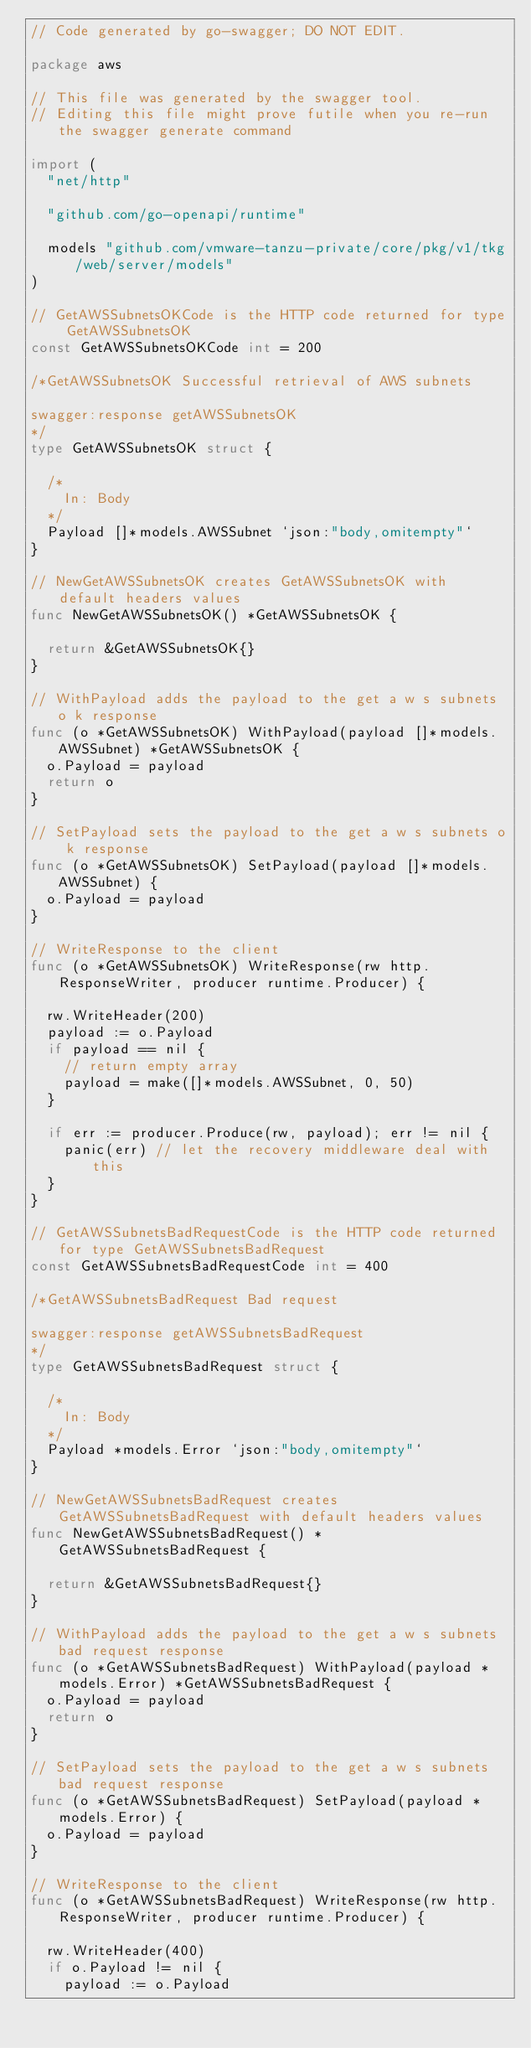Convert code to text. <code><loc_0><loc_0><loc_500><loc_500><_Go_>// Code generated by go-swagger; DO NOT EDIT.

package aws

// This file was generated by the swagger tool.
// Editing this file might prove futile when you re-run the swagger generate command

import (
	"net/http"

	"github.com/go-openapi/runtime"

	models "github.com/vmware-tanzu-private/core/pkg/v1/tkg/web/server/models"
)

// GetAWSSubnetsOKCode is the HTTP code returned for type GetAWSSubnetsOK
const GetAWSSubnetsOKCode int = 200

/*GetAWSSubnetsOK Successful retrieval of AWS subnets

swagger:response getAWSSubnetsOK
*/
type GetAWSSubnetsOK struct {

	/*
	  In: Body
	*/
	Payload []*models.AWSSubnet `json:"body,omitempty"`
}

// NewGetAWSSubnetsOK creates GetAWSSubnetsOK with default headers values
func NewGetAWSSubnetsOK() *GetAWSSubnetsOK {

	return &GetAWSSubnetsOK{}
}

// WithPayload adds the payload to the get a w s subnets o k response
func (o *GetAWSSubnetsOK) WithPayload(payload []*models.AWSSubnet) *GetAWSSubnetsOK {
	o.Payload = payload
	return o
}

// SetPayload sets the payload to the get a w s subnets o k response
func (o *GetAWSSubnetsOK) SetPayload(payload []*models.AWSSubnet) {
	o.Payload = payload
}

// WriteResponse to the client
func (o *GetAWSSubnetsOK) WriteResponse(rw http.ResponseWriter, producer runtime.Producer) {

	rw.WriteHeader(200)
	payload := o.Payload
	if payload == nil {
		// return empty array
		payload = make([]*models.AWSSubnet, 0, 50)
	}

	if err := producer.Produce(rw, payload); err != nil {
		panic(err) // let the recovery middleware deal with this
	}
}

// GetAWSSubnetsBadRequestCode is the HTTP code returned for type GetAWSSubnetsBadRequest
const GetAWSSubnetsBadRequestCode int = 400

/*GetAWSSubnetsBadRequest Bad request

swagger:response getAWSSubnetsBadRequest
*/
type GetAWSSubnetsBadRequest struct {

	/*
	  In: Body
	*/
	Payload *models.Error `json:"body,omitempty"`
}

// NewGetAWSSubnetsBadRequest creates GetAWSSubnetsBadRequest with default headers values
func NewGetAWSSubnetsBadRequest() *GetAWSSubnetsBadRequest {

	return &GetAWSSubnetsBadRequest{}
}

// WithPayload adds the payload to the get a w s subnets bad request response
func (o *GetAWSSubnetsBadRequest) WithPayload(payload *models.Error) *GetAWSSubnetsBadRequest {
	o.Payload = payload
	return o
}

// SetPayload sets the payload to the get a w s subnets bad request response
func (o *GetAWSSubnetsBadRequest) SetPayload(payload *models.Error) {
	o.Payload = payload
}

// WriteResponse to the client
func (o *GetAWSSubnetsBadRequest) WriteResponse(rw http.ResponseWriter, producer runtime.Producer) {

	rw.WriteHeader(400)
	if o.Payload != nil {
		payload := o.Payload</code> 